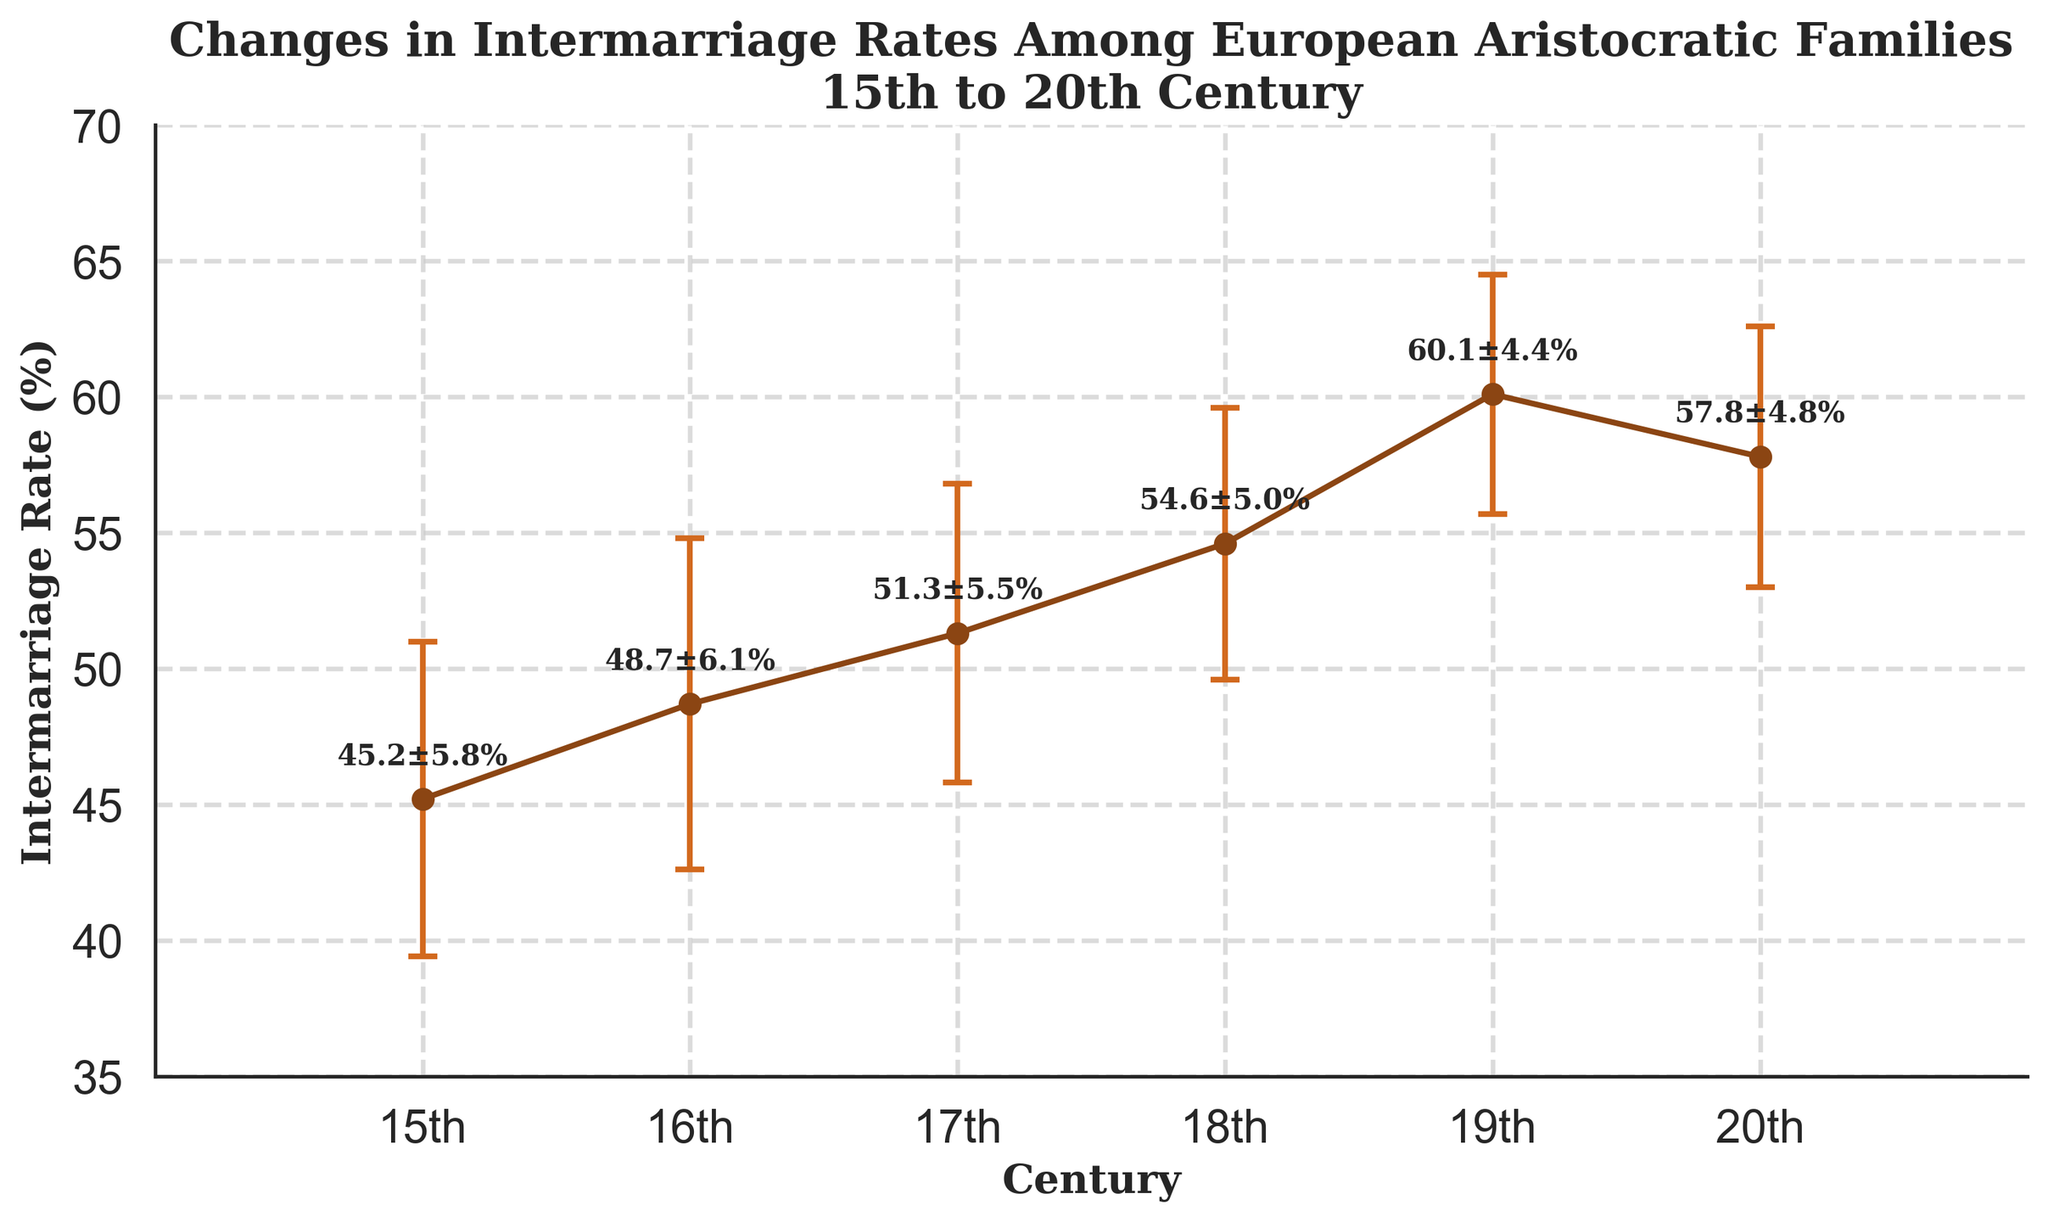How many centuries are depicted in the plot? Count the intervals on the x-axis labeled from the 15th to the 20th century. The plot shows data from 6 centuries.
Answer: 6 What is the intermarriage rate in the 19th century? Locate the point on the line plot at the 19th century and read the corresponding value on the y-axis. The rate is 60.1%.
Answer: 60.1% Which century has the lowest intermarriage rate depicted? Compare all the y-values to determine the lowest one. The 15th century has the lowest intermarriage rate of 45.2%.
Answer: 15th century How does the intermarriage rate change from the 18th to the 19th century? Look at the intermarriage rates in the 18th and 19th centuries and calculate the difference: 60.1% - 54.6% = 5.5%. There is an increase of 5.5%.
Answer: Increase by 5.5% What is the largest error margin shown in the figure? Identify the error margins for each century and find the maximum value. The largest error margin is 6.1% in the 16th century.
Answer: 6.1% What trend do you observe in the intermarriage rates from the 15th century to the 20th century? Examine the line connecting the data points across the centuries. The intermarriage rate generally increases from the 15th to the 19th century and then slightly decreases in the 20th century.
Answer: Increasing then slightly decreasing In which century does the intermarriage rate experience the highest growth compared to the previous century? Calculate the differences between the intermarriage rates of each consecutive century and determine the highest one. The highest growth is from the 18th to the 19th century with an increase of 60.1% - 54.6% = 5.5%.
Answer: From 18th to 19th century How do the error margins vary across the centuries? Observe the error bars (± values) for each century and compare them. The error margins generally decrease from 5.8% in the 15th century to 4.4% in the 19th century and then slightly increase to 4.8% in the 20th century.
Answer: Decrease then slightly increase 